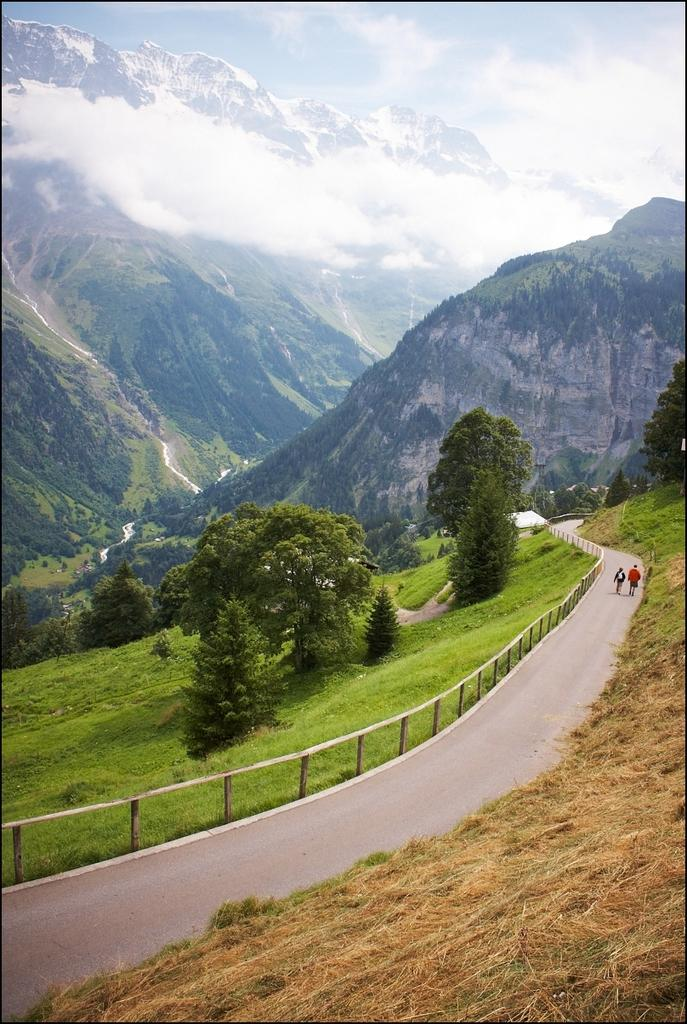What type of vegetation can be seen in the image? There are trees in the image. What are the people in the image doing? People are walking on the road in the image. What is visible in the background of the image? The sky is visible in the image. Can you tell me how many boats are docked near the trees in the image? There are no boats present in the image; it features trees and people walking on a road. What type of lettuce can be seen growing near the people walking in the image? There is no lettuce visible in the image; it only features trees and people walking on a road. 